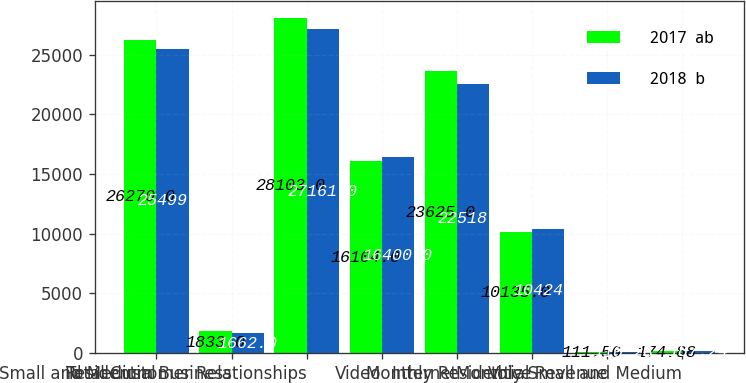Convert chart. <chart><loc_0><loc_0><loc_500><loc_500><stacked_bar_chart><ecel><fcel>Residential<fcel>Small and Medium Business<fcel>Total Customer Relationships<fcel>Video<fcel>Internet<fcel>Voice<fcel>Monthly Residential Revenue<fcel>Monthly Small and Medium<nl><fcel>2017  ab<fcel>26270<fcel>1833<fcel>28103<fcel>16104<fcel>23625<fcel>10135<fcel>111.56<fcel>174.88<nl><fcel>2018  b<fcel>25499<fcel>1662<fcel>27161<fcel>16400<fcel>22518<fcel>10424<fcel>110.28<fcel>187.24<nl></chart> 